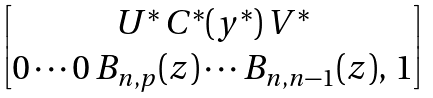<formula> <loc_0><loc_0><loc_500><loc_500>\begin{bmatrix} U ^ { * } \, C ^ { * } ( y ^ { * } ) \, V ^ { * } \\ 0 \cdots 0 \, B _ { n , p } ( z ) \cdots B _ { n , n - 1 } ( z ) , \, 1 \end{bmatrix}</formula> 